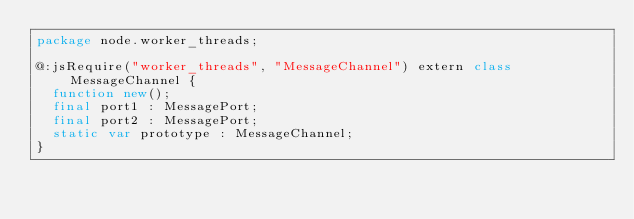Convert code to text. <code><loc_0><loc_0><loc_500><loc_500><_Haxe_>package node.worker_threads;

@:jsRequire("worker_threads", "MessageChannel") extern class MessageChannel {
	function new();
	final port1 : MessagePort;
	final port2 : MessagePort;
	static var prototype : MessageChannel;
}</code> 